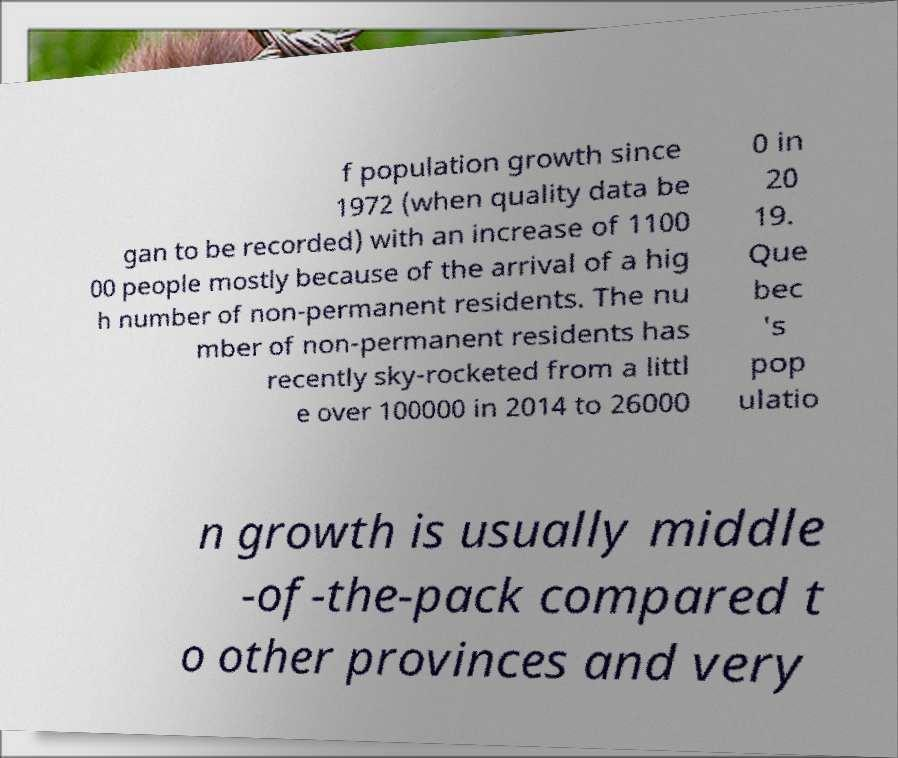For documentation purposes, I need the text within this image transcribed. Could you provide that? f population growth since 1972 (when quality data be gan to be recorded) with an increase of 1100 00 people mostly because of the arrival of a hig h number of non-permanent residents. The nu mber of non-permanent residents has recently sky-rocketed from a littl e over 100000 in 2014 to 26000 0 in 20 19. Que bec 's pop ulatio n growth is usually middle -of-the-pack compared t o other provinces and very 